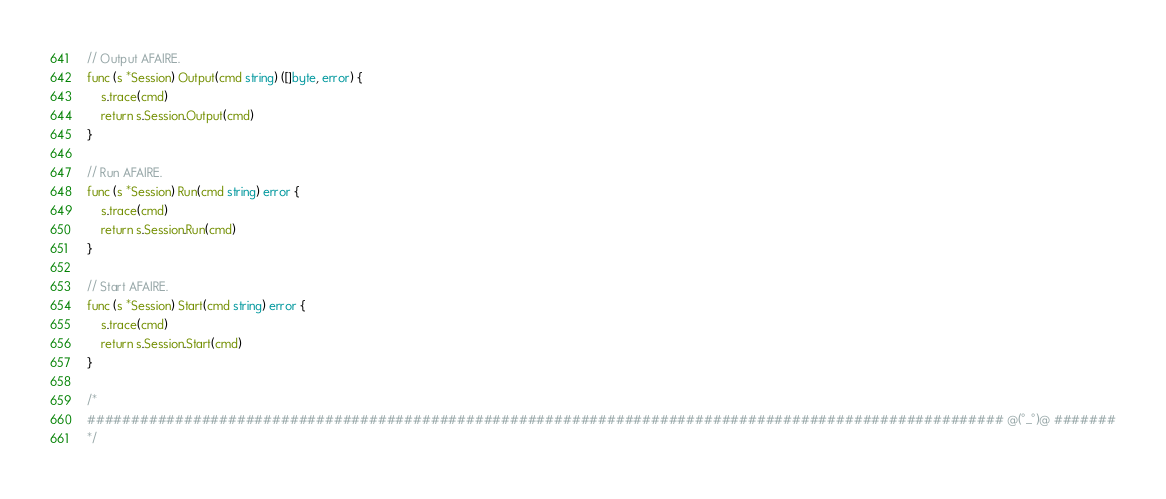<code> <loc_0><loc_0><loc_500><loc_500><_Go_>
// Output AFAIRE.
func (s *Session) Output(cmd string) ([]byte, error) {
	s.trace(cmd)
	return s.Session.Output(cmd)
}

// Run AFAIRE.
func (s *Session) Run(cmd string) error {
	s.trace(cmd)
	return s.Session.Run(cmd)
}

// Start AFAIRE.
func (s *Session) Start(cmd string) error {
	s.trace(cmd)
	return s.Session.Start(cmd)
}

/*
######################################################################################################## @(°_°)@ #######
*/
</code> 